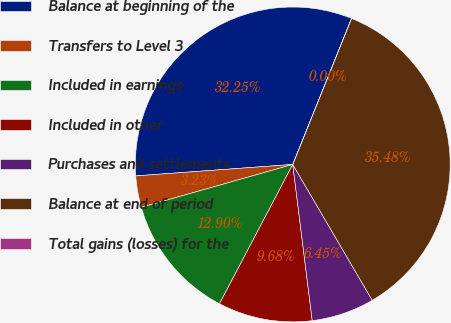Convert chart. <chart><loc_0><loc_0><loc_500><loc_500><pie_chart><fcel>Balance at beginning of the<fcel>Transfers to Level 3<fcel>Included in earnings<fcel>Included in other<fcel>Purchases and settlements<fcel>Balance at end of period<fcel>Total gains (losses) for the<nl><fcel>32.25%<fcel>3.23%<fcel>12.9%<fcel>9.68%<fcel>6.45%<fcel>35.48%<fcel>0.0%<nl></chart> 